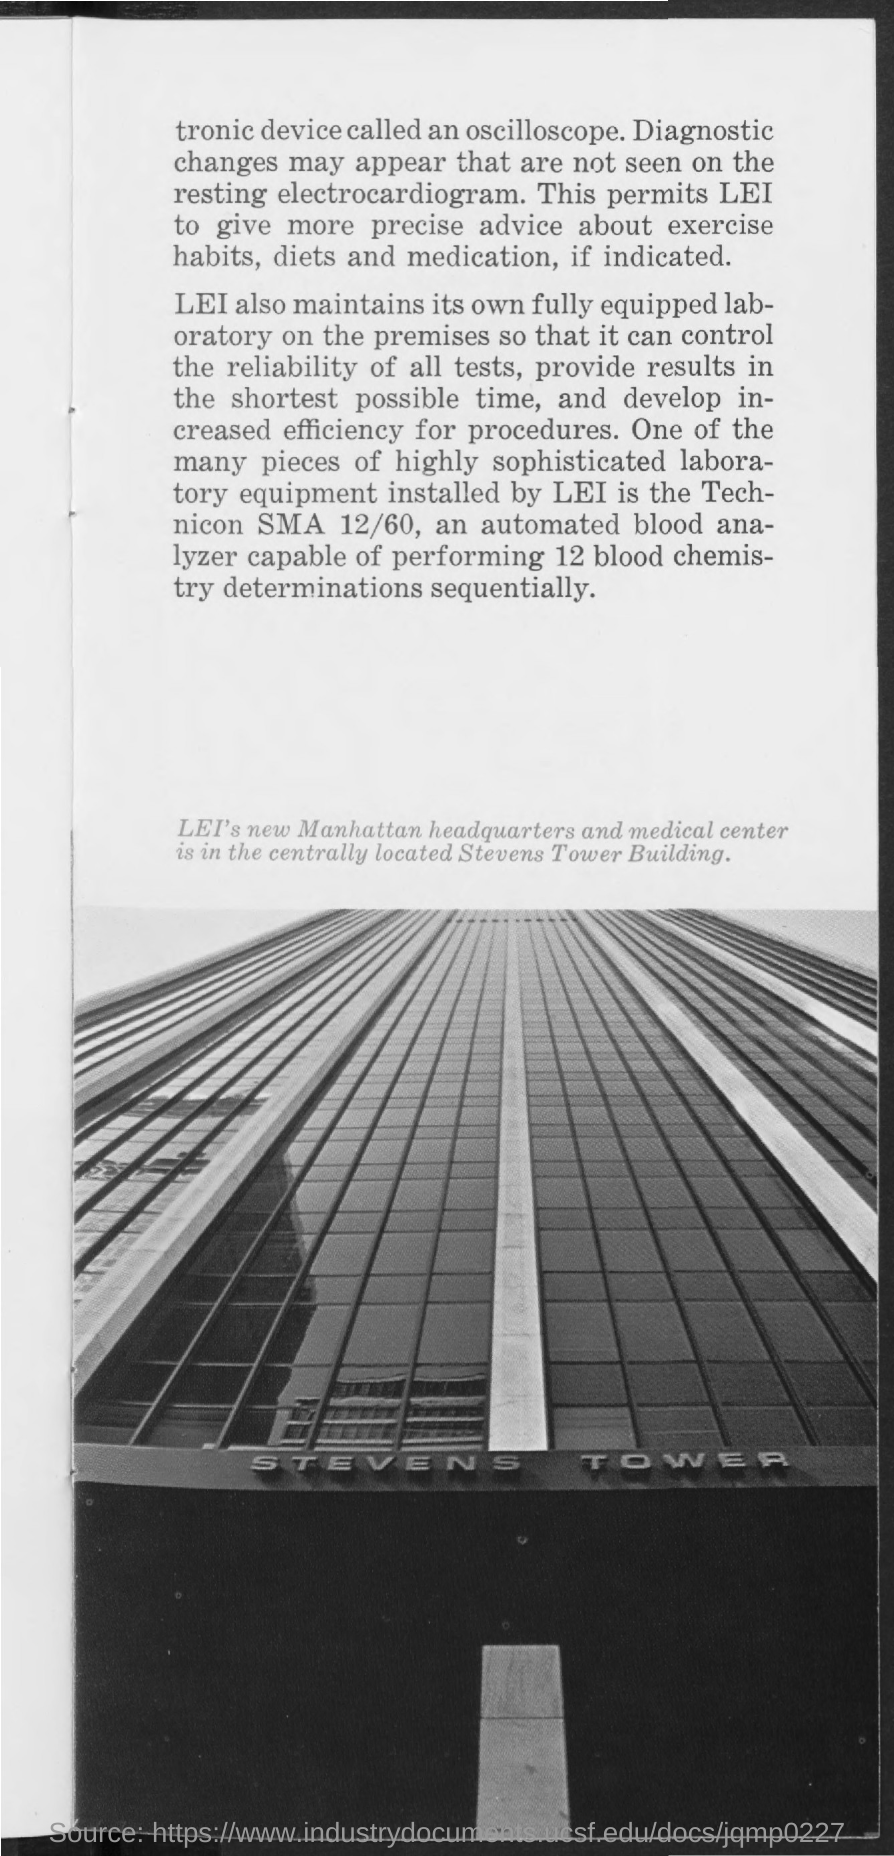Highlight a few significant elements in this photo. Technicon is capable of conducting 12 blood chemistry determinations. The location of LEI's new Manhattan Headquarters and medical center is the Stevens Tower Building. 